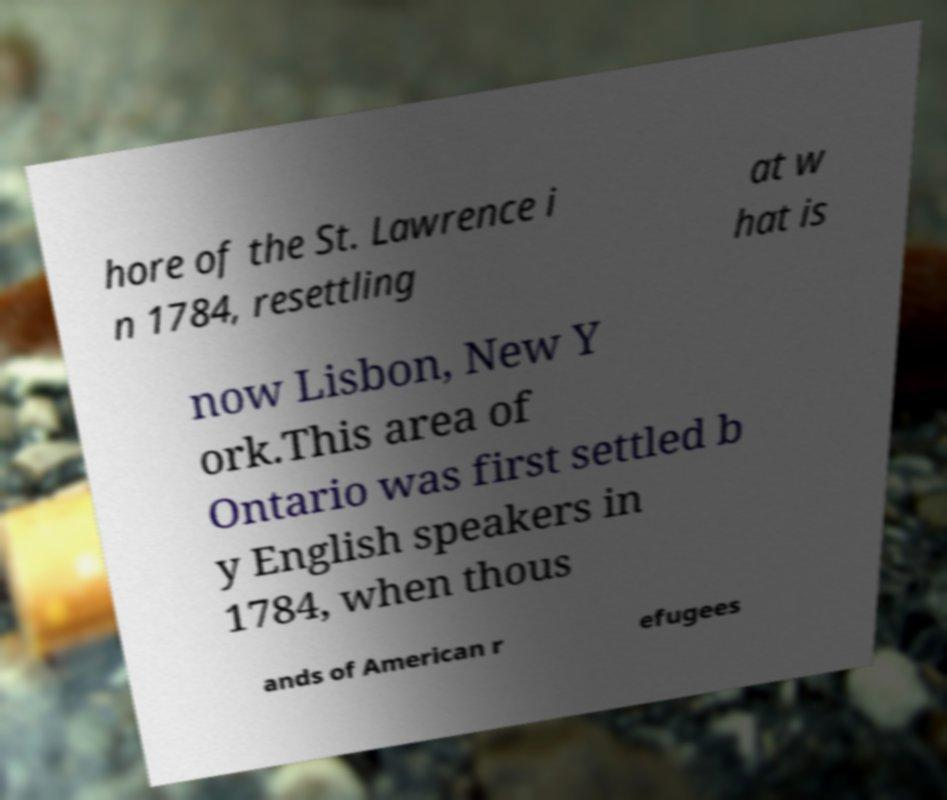What messages or text are displayed in this image? I need them in a readable, typed format. hore of the St. Lawrence i n 1784, resettling at w hat is now Lisbon, New Y ork.This area of Ontario was first settled b y English speakers in 1784, when thous ands of American r efugees 